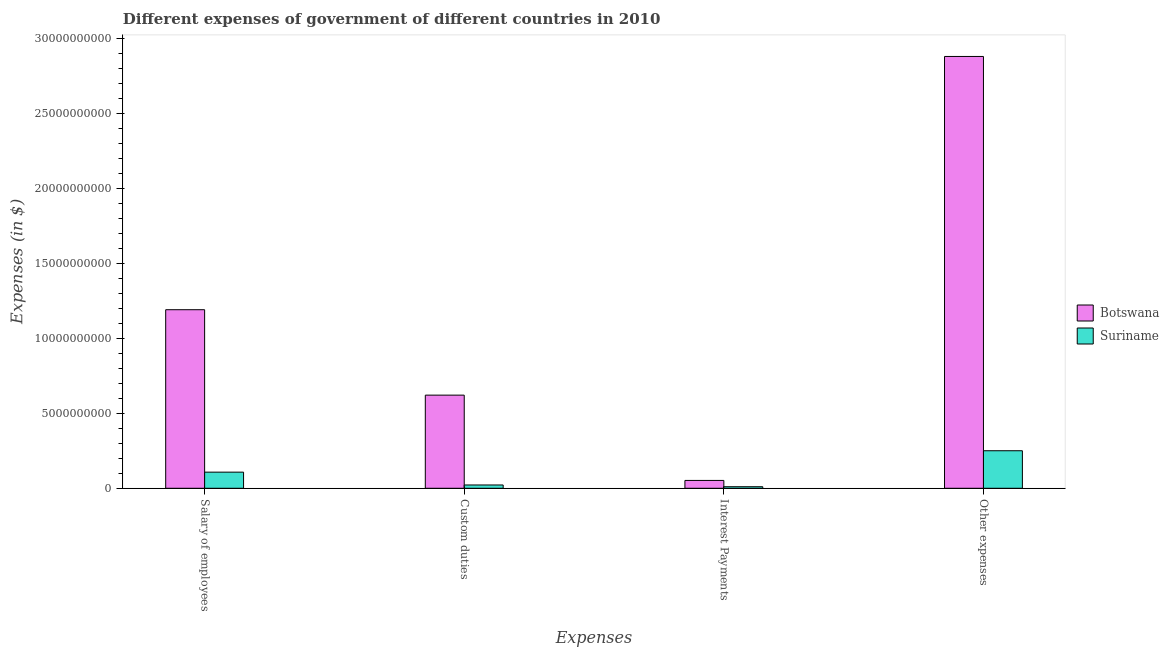How many different coloured bars are there?
Make the answer very short. 2. How many groups of bars are there?
Provide a succinct answer. 4. Are the number of bars on each tick of the X-axis equal?
Provide a short and direct response. Yes. How many bars are there on the 3rd tick from the left?
Offer a very short reply. 2. How many bars are there on the 3rd tick from the right?
Your answer should be very brief. 2. What is the label of the 4th group of bars from the left?
Ensure brevity in your answer.  Other expenses. What is the amount spent on salary of employees in Botswana?
Ensure brevity in your answer.  1.19e+1. Across all countries, what is the maximum amount spent on custom duties?
Keep it short and to the point. 6.21e+09. Across all countries, what is the minimum amount spent on salary of employees?
Offer a terse response. 1.08e+09. In which country was the amount spent on interest payments maximum?
Provide a short and direct response. Botswana. In which country was the amount spent on other expenses minimum?
Provide a short and direct response. Suriname. What is the total amount spent on salary of employees in the graph?
Provide a succinct answer. 1.30e+1. What is the difference between the amount spent on salary of employees in Suriname and that in Botswana?
Make the answer very short. -1.08e+1. What is the difference between the amount spent on interest payments in Suriname and the amount spent on custom duties in Botswana?
Give a very brief answer. -6.10e+09. What is the average amount spent on salary of employees per country?
Provide a succinct answer. 6.49e+09. What is the difference between the amount spent on custom duties and amount spent on interest payments in Suriname?
Give a very brief answer. 1.17e+08. In how many countries, is the amount spent on salary of employees greater than 27000000000 $?
Your response must be concise. 0. What is the ratio of the amount spent on other expenses in Botswana to that in Suriname?
Your response must be concise. 11.5. What is the difference between the highest and the second highest amount spent on salary of employees?
Ensure brevity in your answer.  1.08e+1. What is the difference between the highest and the lowest amount spent on custom duties?
Ensure brevity in your answer.  5.99e+09. In how many countries, is the amount spent on custom duties greater than the average amount spent on custom duties taken over all countries?
Provide a short and direct response. 1. Is the sum of the amount spent on other expenses in Suriname and Botswana greater than the maximum amount spent on interest payments across all countries?
Offer a terse response. Yes. What does the 2nd bar from the left in Interest Payments represents?
Keep it short and to the point. Suriname. What does the 1st bar from the right in Salary of employees represents?
Your answer should be compact. Suriname. How many bars are there?
Offer a terse response. 8. Are all the bars in the graph horizontal?
Your answer should be very brief. No. What is the difference between two consecutive major ticks on the Y-axis?
Keep it short and to the point. 5.00e+09. Does the graph contain grids?
Give a very brief answer. No. Where does the legend appear in the graph?
Your answer should be very brief. Center right. What is the title of the graph?
Make the answer very short. Different expenses of government of different countries in 2010. Does "Lesotho" appear as one of the legend labels in the graph?
Make the answer very short. No. What is the label or title of the X-axis?
Make the answer very short. Expenses. What is the label or title of the Y-axis?
Ensure brevity in your answer.  Expenses (in $). What is the Expenses (in $) of Botswana in Salary of employees?
Your answer should be very brief. 1.19e+1. What is the Expenses (in $) of Suriname in Salary of employees?
Ensure brevity in your answer.  1.08e+09. What is the Expenses (in $) of Botswana in Custom duties?
Ensure brevity in your answer.  6.21e+09. What is the Expenses (in $) of Suriname in Custom duties?
Your answer should be very brief. 2.21e+08. What is the Expenses (in $) of Botswana in Interest Payments?
Make the answer very short. 5.24e+08. What is the Expenses (in $) in Suriname in Interest Payments?
Offer a terse response. 1.04e+08. What is the Expenses (in $) in Botswana in Other expenses?
Provide a succinct answer. 2.88e+1. What is the Expenses (in $) in Suriname in Other expenses?
Provide a short and direct response. 2.50e+09. Across all Expenses, what is the maximum Expenses (in $) in Botswana?
Provide a succinct answer. 2.88e+1. Across all Expenses, what is the maximum Expenses (in $) of Suriname?
Provide a succinct answer. 2.50e+09. Across all Expenses, what is the minimum Expenses (in $) of Botswana?
Provide a short and direct response. 5.24e+08. Across all Expenses, what is the minimum Expenses (in $) in Suriname?
Your answer should be compact. 1.04e+08. What is the total Expenses (in $) of Botswana in the graph?
Provide a short and direct response. 4.74e+1. What is the total Expenses (in $) of Suriname in the graph?
Your answer should be very brief. 3.90e+09. What is the difference between the Expenses (in $) in Botswana in Salary of employees and that in Custom duties?
Ensure brevity in your answer.  5.69e+09. What is the difference between the Expenses (in $) in Suriname in Salary of employees and that in Custom duties?
Provide a short and direct response. 8.54e+08. What is the difference between the Expenses (in $) of Botswana in Salary of employees and that in Interest Payments?
Provide a short and direct response. 1.14e+1. What is the difference between the Expenses (in $) in Suriname in Salary of employees and that in Interest Payments?
Provide a short and direct response. 9.72e+08. What is the difference between the Expenses (in $) in Botswana in Salary of employees and that in Other expenses?
Make the answer very short. -1.69e+1. What is the difference between the Expenses (in $) in Suriname in Salary of employees and that in Other expenses?
Keep it short and to the point. -1.43e+09. What is the difference between the Expenses (in $) of Botswana in Custom duties and that in Interest Payments?
Ensure brevity in your answer.  5.68e+09. What is the difference between the Expenses (in $) in Suriname in Custom duties and that in Interest Payments?
Offer a terse response. 1.17e+08. What is the difference between the Expenses (in $) in Botswana in Custom duties and that in Other expenses?
Keep it short and to the point. -2.26e+1. What is the difference between the Expenses (in $) of Suriname in Custom duties and that in Other expenses?
Your answer should be compact. -2.28e+09. What is the difference between the Expenses (in $) of Botswana in Interest Payments and that in Other expenses?
Ensure brevity in your answer.  -2.83e+1. What is the difference between the Expenses (in $) of Suriname in Interest Payments and that in Other expenses?
Make the answer very short. -2.40e+09. What is the difference between the Expenses (in $) in Botswana in Salary of employees and the Expenses (in $) in Suriname in Custom duties?
Make the answer very short. 1.17e+1. What is the difference between the Expenses (in $) of Botswana in Salary of employees and the Expenses (in $) of Suriname in Interest Payments?
Provide a short and direct response. 1.18e+1. What is the difference between the Expenses (in $) in Botswana in Salary of employees and the Expenses (in $) in Suriname in Other expenses?
Give a very brief answer. 9.40e+09. What is the difference between the Expenses (in $) of Botswana in Custom duties and the Expenses (in $) of Suriname in Interest Payments?
Offer a very short reply. 6.10e+09. What is the difference between the Expenses (in $) of Botswana in Custom duties and the Expenses (in $) of Suriname in Other expenses?
Provide a short and direct response. 3.70e+09. What is the difference between the Expenses (in $) in Botswana in Interest Payments and the Expenses (in $) in Suriname in Other expenses?
Keep it short and to the point. -1.98e+09. What is the average Expenses (in $) of Botswana per Expenses?
Keep it short and to the point. 1.19e+1. What is the average Expenses (in $) of Suriname per Expenses?
Your answer should be very brief. 9.75e+08. What is the difference between the Expenses (in $) in Botswana and Expenses (in $) in Suriname in Salary of employees?
Provide a succinct answer. 1.08e+1. What is the difference between the Expenses (in $) of Botswana and Expenses (in $) of Suriname in Custom duties?
Your answer should be very brief. 5.99e+09. What is the difference between the Expenses (in $) of Botswana and Expenses (in $) of Suriname in Interest Payments?
Offer a very short reply. 4.20e+08. What is the difference between the Expenses (in $) in Botswana and Expenses (in $) in Suriname in Other expenses?
Keep it short and to the point. 2.63e+1. What is the ratio of the Expenses (in $) in Botswana in Salary of employees to that in Custom duties?
Provide a short and direct response. 1.92. What is the ratio of the Expenses (in $) of Suriname in Salary of employees to that in Custom duties?
Offer a very short reply. 4.87. What is the ratio of the Expenses (in $) of Botswana in Salary of employees to that in Interest Payments?
Make the answer very short. 22.73. What is the ratio of the Expenses (in $) in Suriname in Salary of employees to that in Interest Payments?
Offer a very short reply. 10.38. What is the ratio of the Expenses (in $) in Botswana in Salary of employees to that in Other expenses?
Ensure brevity in your answer.  0.41. What is the ratio of the Expenses (in $) in Suriname in Salary of employees to that in Other expenses?
Your answer should be very brief. 0.43. What is the ratio of the Expenses (in $) of Botswana in Custom duties to that in Interest Payments?
Ensure brevity in your answer.  11.86. What is the ratio of the Expenses (in $) of Suriname in Custom duties to that in Interest Payments?
Keep it short and to the point. 2.13. What is the ratio of the Expenses (in $) of Botswana in Custom duties to that in Other expenses?
Provide a short and direct response. 0.22. What is the ratio of the Expenses (in $) of Suriname in Custom duties to that in Other expenses?
Offer a terse response. 0.09. What is the ratio of the Expenses (in $) in Botswana in Interest Payments to that in Other expenses?
Your answer should be compact. 0.02. What is the ratio of the Expenses (in $) of Suriname in Interest Payments to that in Other expenses?
Make the answer very short. 0.04. What is the difference between the highest and the second highest Expenses (in $) in Botswana?
Provide a short and direct response. 1.69e+1. What is the difference between the highest and the second highest Expenses (in $) of Suriname?
Your answer should be compact. 1.43e+09. What is the difference between the highest and the lowest Expenses (in $) in Botswana?
Your answer should be very brief. 2.83e+1. What is the difference between the highest and the lowest Expenses (in $) in Suriname?
Your response must be concise. 2.40e+09. 